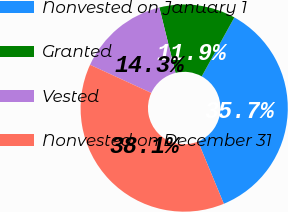Convert chart to OTSL. <chart><loc_0><loc_0><loc_500><loc_500><pie_chart><fcel>Nonvested on January 1<fcel>Granted<fcel>Vested<fcel>Nonvested on December 31<nl><fcel>35.71%<fcel>11.9%<fcel>14.29%<fcel>38.1%<nl></chart> 